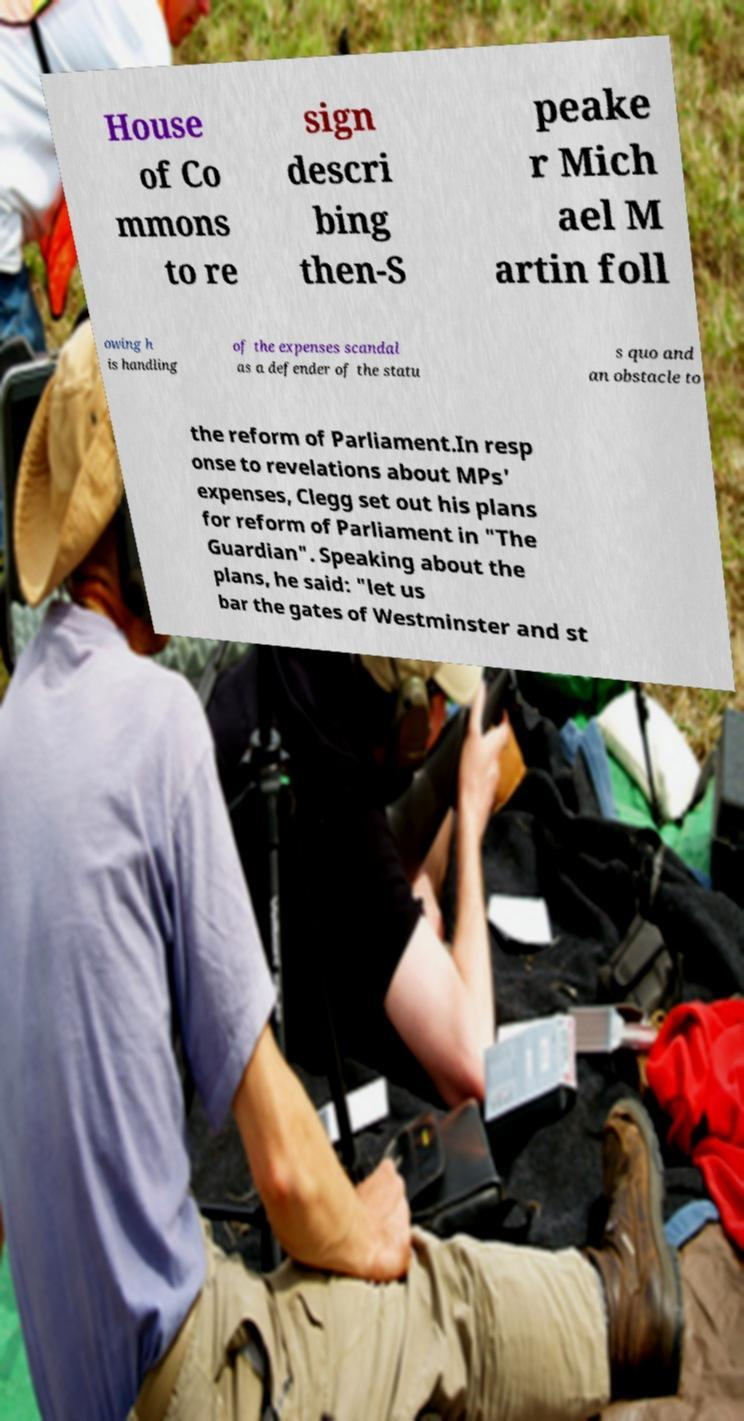I need the written content from this picture converted into text. Can you do that? House of Co mmons to re sign descri bing then-S peake r Mich ael M artin foll owing h is handling of the expenses scandal as a defender of the statu s quo and an obstacle to the reform of Parliament.In resp onse to revelations about MPs' expenses, Clegg set out his plans for reform of Parliament in "The Guardian". Speaking about the plans, he said: "let us bar the gates of Westminster and st 